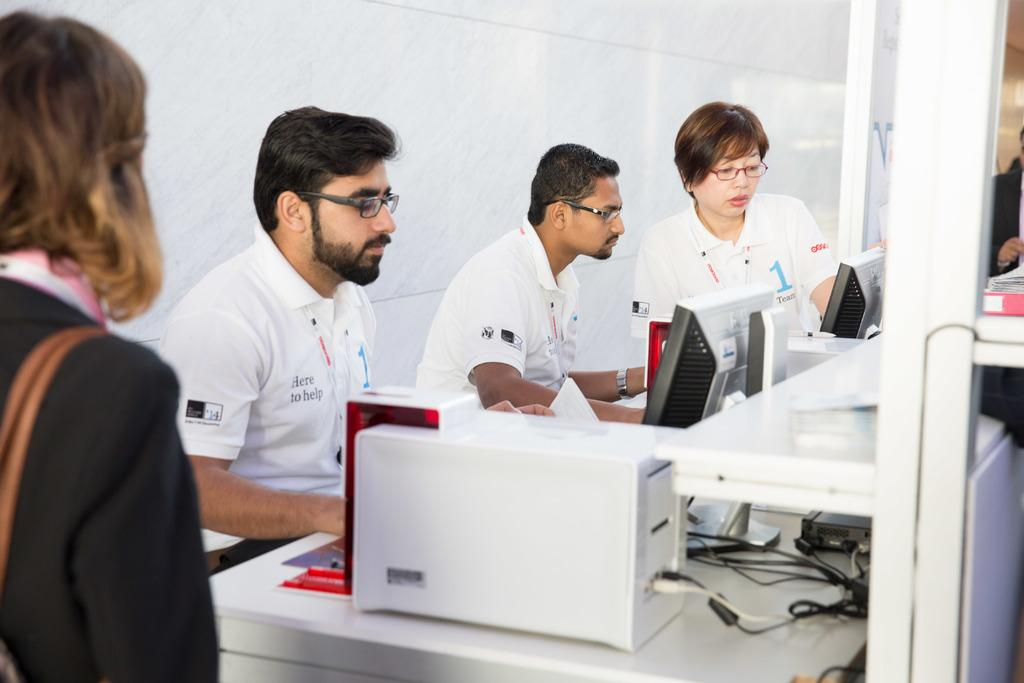What are the people in the image doing? The people in the image are sitting and looking at monitors. What can be seen behind the people in the image? There is a wall visible in the image. What type of toy can be seen in the hands of the people in the image? There are no toys present in the image; the people are looking at monitors. 